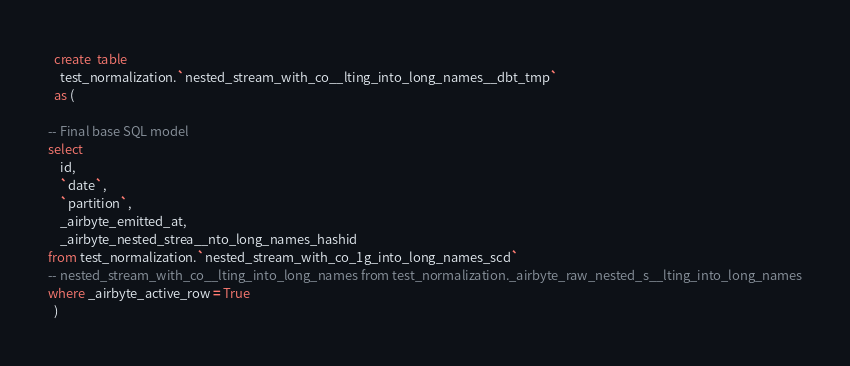Convert code to text. <code><loc_0><loc_0><loc_500><loc_500><_SQL_>

  create  table
    test_normalization.`nested_stream_with_co__lting_into_long_names__dbt_tmp`
  as (
    
-- Final base SQL model
select
    id,
    `date`,
    `partition`,
    _airbyte_emitted_at,
    _airbyte_nested_strea__nto_long_names_hashid
from test_normalization.`nested_stream_with_co_1g_into_long_names_scd`
-- nested_stream_with_co__lting_into_long_names from test_normalization._airbyte_raw_nested_s__lting_into_long_names
where _airbyte_active_row = True
  )
</code> 